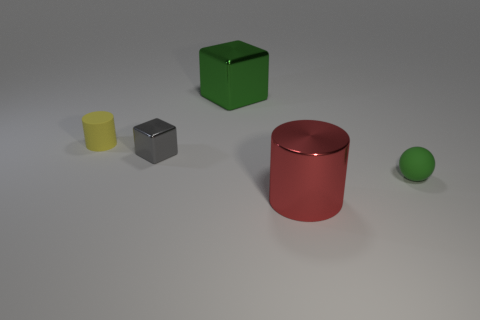What is the cylinder that is on the left side of the big shiny thing that is behind the yellow rubber cylinder made of?
Keep it short and to the point. Rubber. Are there fewer red cylinders that are behind the tiny rubber sphere than big purple rubber cylinders?
Ensure brevity in your answer.  No. The big red thing that is made of the same material as the tiny block is what shape?
Offer a terse response. Cylinder. How many other objects are the same shape as the small gray metallic object?
Keep it short and to the point. 1. How many blue objects are either shiny cylinders or large cubes?
Your answer should be compact. 0. Is the shape of the red metal thing the same as the tiny green object?
Your response must be concise. No. Are there any red things in front of the tiny object that is in front of the small gray metallic block?
Your answer should be compact. Yes. Are there an equal number of green cubes in front of the gray cube and tiny yellow shiny cylinders?
Your answer should be compact. Yes. What number of other objects are the same size as the green sphere?
Provide a succinct answer. 2. Do the big thing in front of the green matte thing and the thing to the right of the large red metallic object have the same material?
Keep it short and to the point. No. 